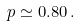Convert formula to latex. <formula><loc_0><loc_0><loc_500><loc_500>p \simeq 0 . 8 0 \, .</formula> 